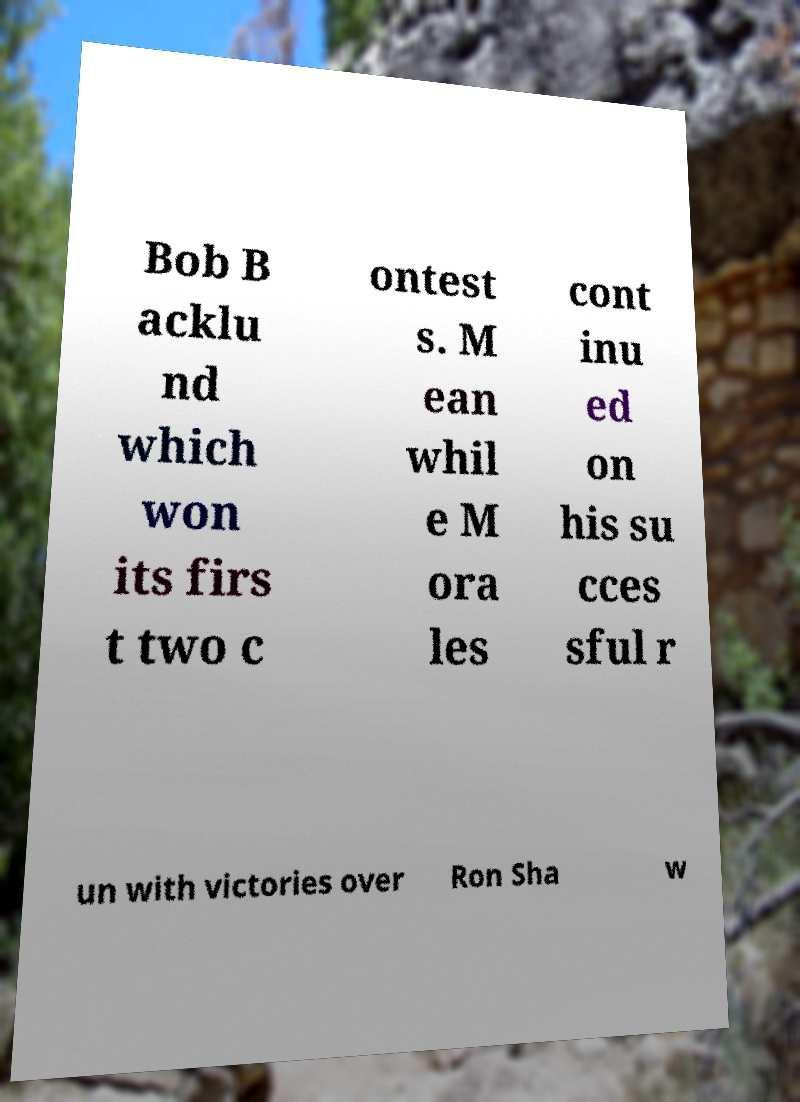Could you extract and type out the text from this image? Bob B acklu nd which won its firs t two c ontest s. M ean whil e M ora les cont inu ed on his su cces sful r un with victories over Ron Sha w 